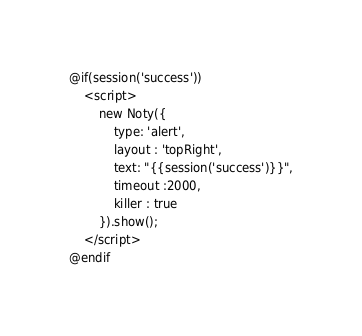Convert code to text. <code><loc_0><loc_0><loc_500><loc_500><_PHP_>@if(session('success'))
    <script>
        new Noty({
            type: 'alert',
            layout : 'topRight',
            text: "{{session('success')}}",
            timeout :2000,
            killer : true
        }).show();
    </script>
@endif
</code> 